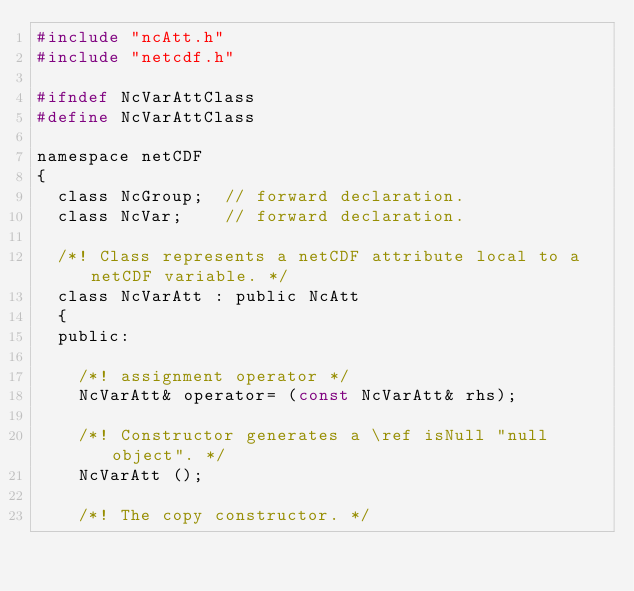Convert code to text. <code><loc_0><loc_0><loc_500><loc_500><_C_>#include "ncAtt.h"
#include "netcdf.h"

#ifndef NcVarAttClass
#define NcVarAttClass

namespace netCDF
{
  class NcGroup;  // forward declaration.
  class NcVar;    // forward declaration.

  /*! Class represents a netCDF attribute local to a netCDF variable. */
  class NcVarAtt : public NcAtt
  {
  public:
    
    /*! assignment operator */
    NcVarAtt& operator= (const NcVarAtt& rhs);
      
    /*! Constructor generates a \ref isNull "null object". */
    NcVarAtt ();

    /*! The copy constructor. */</code> 